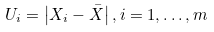<formula> <loc_0><loc_0><loc_500><loc_500>U _ { i } = \left | X _ { i } - \bar { X } \right | , i = 1 , \dots , m</formula> 